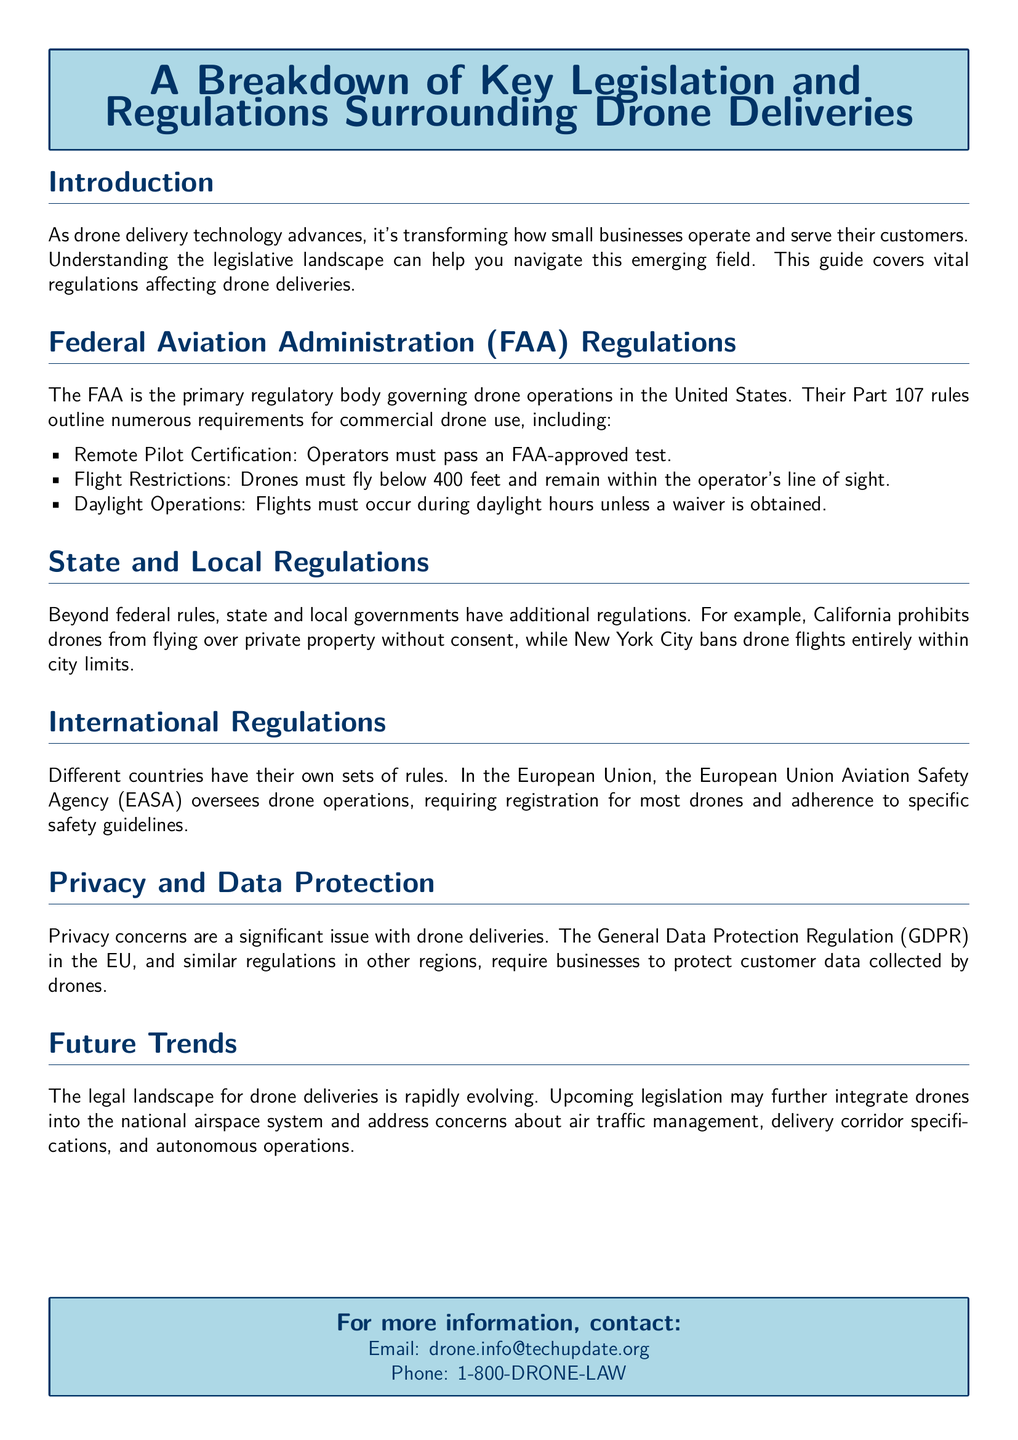What regulatory body governs drone operations in the United States? The document states that the FAA is the primary regulatory body governing drone operations in the U.S.
Answer: FAA What is required for drone operators under Part 107 rules? The document mentions that operators must pass an FAA-approved test for Remote Pilot Certification.
Answer: FAA-approved test What is the maximum altitude for drone flights according to FAA regulations? The document indicates that drones must fly below 400 feet.
Answer: 400 feet Which state's regulations prohibit drones from flying over private property without consent? The document specifies that California prohibits drones from flying over private property without consent.
Answer: California What European agency oversees drone operations and requires registration? The document states that the European Union Aviation Safety Agency (EASA) oversees drone operations.
Answer: EASA What is a concern mentioned in the document regarding drone deliveries? The document highlights privacy concerns as a significant issue with drone deliveries.
Answer: Privacy concerns What legislation may further integrate drones into the national airspace system? The future trends section hints at upcoming legislation addressing autonomous operations and air traffic management.
Answer: Upcoming legislation What is the email address provided for more information in the document? The document lists "drone.info@techupdate.org" as the contact email for more information.
Answer: drone.info@techupdate.org What is a key focus of the General Data Protection Regulation (GDPR) mentioned in the document? The document points out that GDPR requires businesses to protect customer data collected by drones.
Answer: Protect customer data What type of operations must drone flights occur during, according to FAA regulations? The document states that flights must occur during daylight hours unless a waiver is obtained.
Answer: Daylight hours 